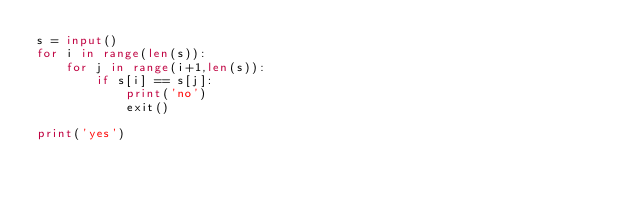Convert code to text. <code><loc_0><loc_0><loc_500><loc_500><_Python_>s = input()
for i in range(len(s)):
    for j in range(i+1,len(s)):
        if s[i] == s[j]:
            print('no')
            exit()
    
print('yes')</code> 